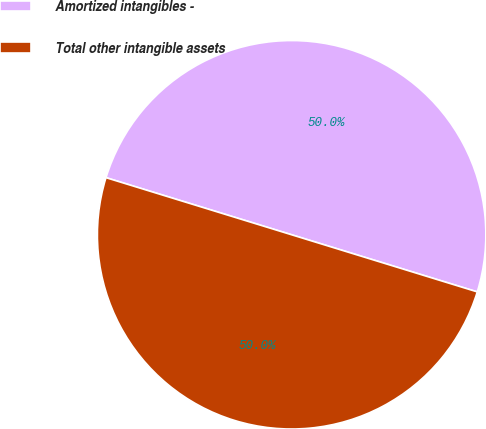Convert chart to OTSL. <chart><loc_0><loc_0><loc_500><loc_500><pie_chart><fcel>Amortized intangibles -<fcel>Total other intangible assets<nl><fcel>50.0%<fcel>50.0%<nl></chart> 